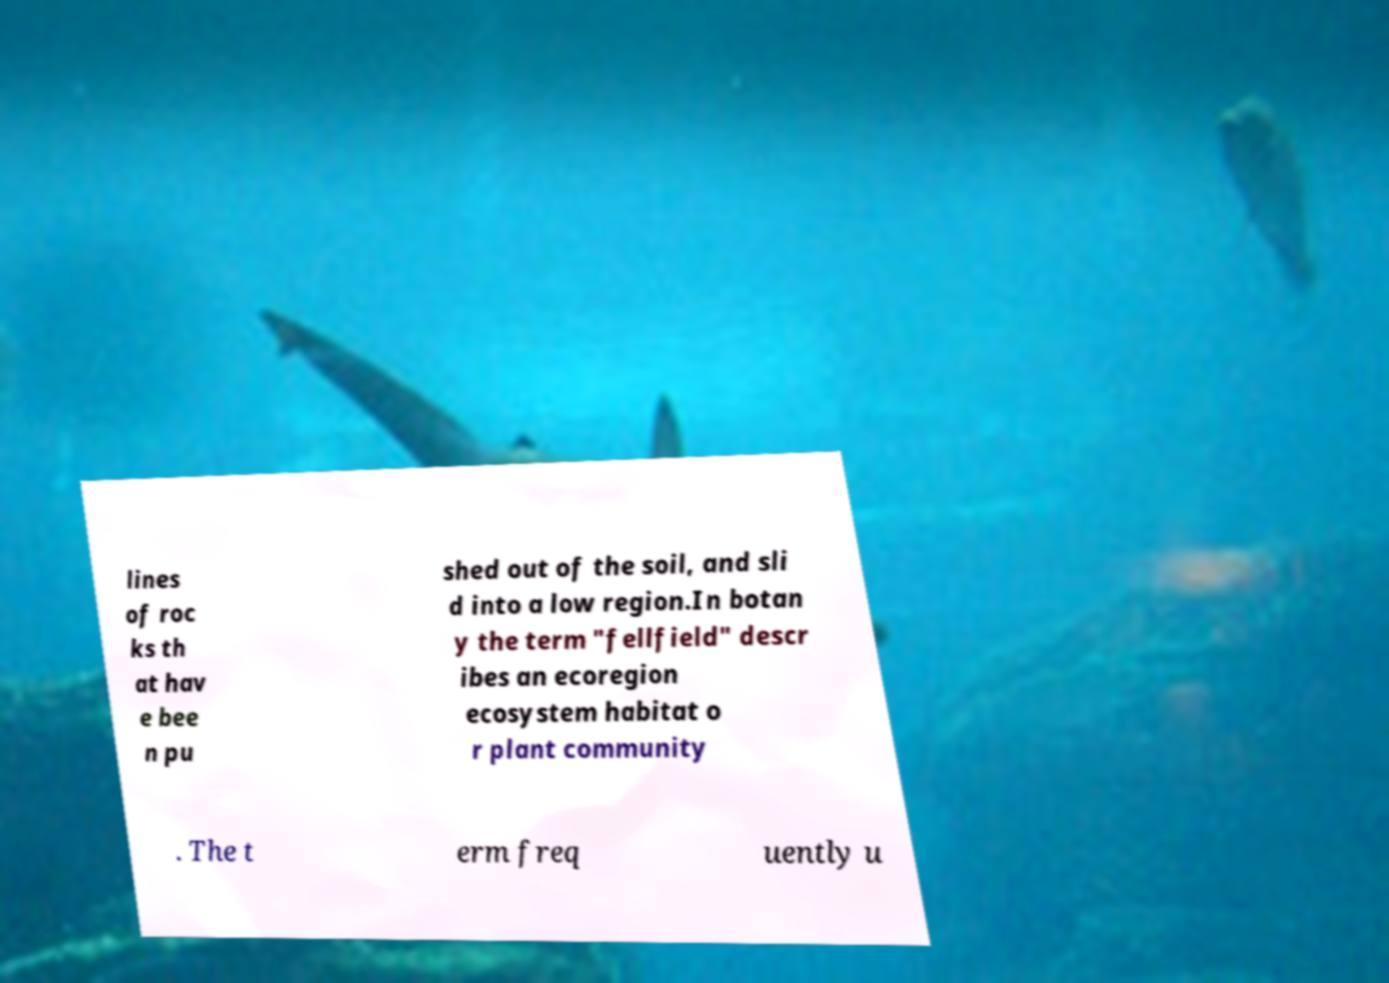Can you read and provide the text displayed in the image?This photo seems to have some interesting text. Can you extract and type it out for me? lines of roc ks th at hav e bee n pu shed out of the soil, and sli d into a low region.In botan y the term "fellfield" descr ibes an ecoregion ecosystem habitat o r plant community . The t erm freq uently u 